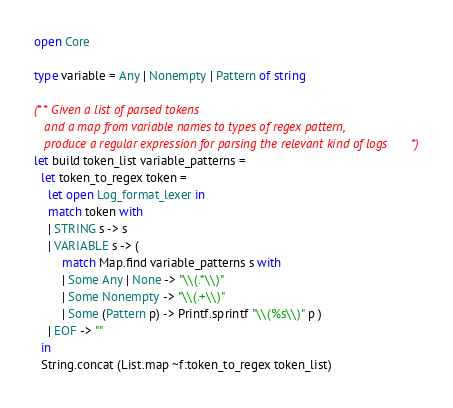Convert code to text. <code><loc_0><loc_0><loc_500><loc_500><_OCaml_>open Core

type variable = Any | Nonempty | Pattern of string

(** Given a list of parsed tokens
   and a map from variable names to types of regex pattern,
   produce a regular expression for parsing the relevant kind of logs *)
let build token_list variable_patterns =
  let token_to_regex token =
    let open Log_format_lexer in
    match token with
    | STRING s -> s
    | VARIABLE s -> (
        match Map.find variable_patterns s with
        | Some Any | None -> "\\(.*\\)"
        | Some Nonempty -> "\\(.+\\)"
        | Some (Pattern p) -> Printf.sprintf "\\(%s\\)" p )
    | EOF -> ""
  in
  String.concat (List.map ~f:token_to_regex token_list)
</code> 